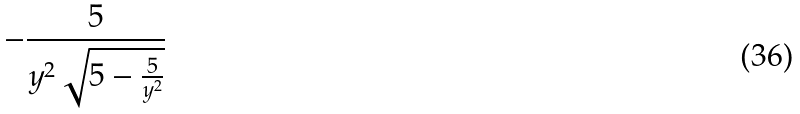Convert formula to latex. <formula><loc_0><loc_0><loc_500><loc_500>- \frac { 5 } { y ^ { 2 } \sqrt { 5 - \frac { 5 } { y ^ { 2 } } } }</formula> 